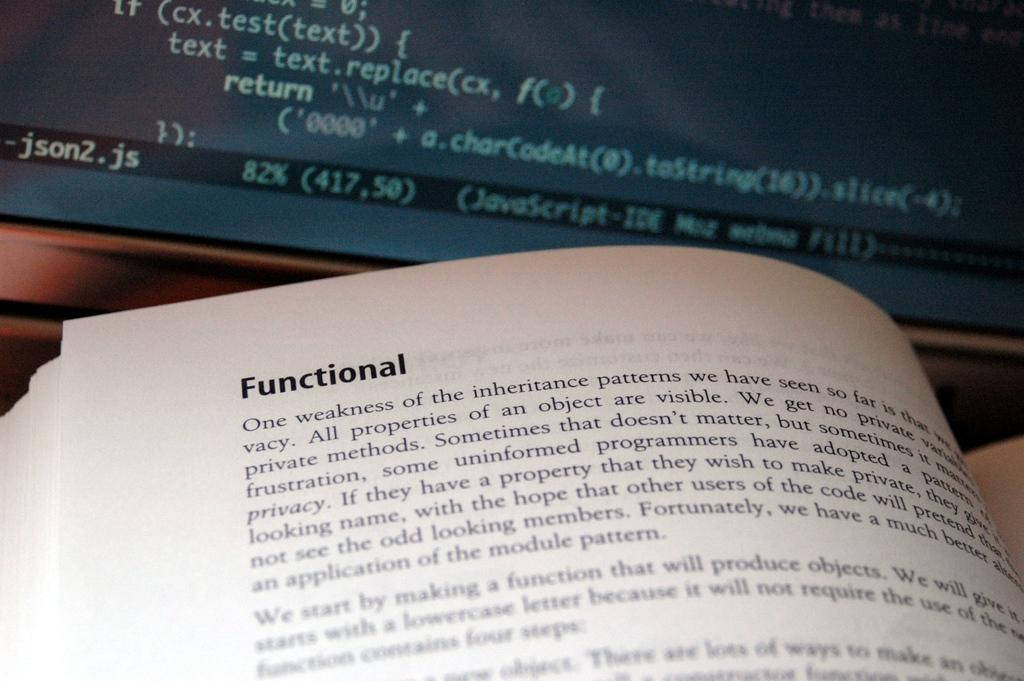Provide a one-sentence caption for the provided image. a book that has the word functional at the top. 